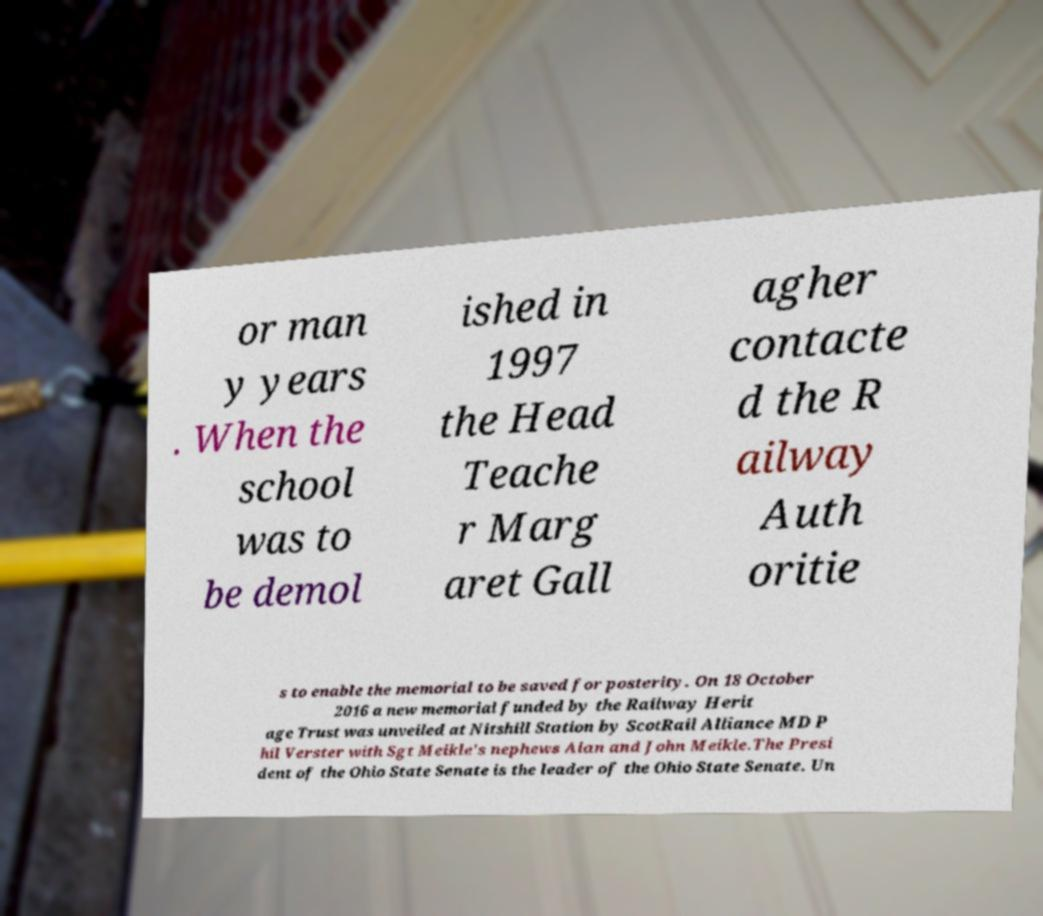Can you accurately transcribe the text from the provided image for me? or man y years . When the school was to be demol ished in 1997 the Head Teache r Marg aret Gall agher contacte d the R ailway Auth oritie s to enable the memorial to be saved for posterity. On 18 October 2016 a new memorial funded by the Railway Herit age Trust was unveiled at Nitshill Station by ScotRail Alliance MD P hil Verster with Sgt Meikle's nephews Alan and John Meikle.The Presi dent of the Ohio State Senate is the leader of the Ohio State Senate. Un 